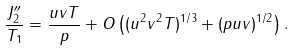Convert formula to latex. <formula><loc_0><loc_0><loc_500><loc_500>\frac { J _ { 2 } ^ { \prime \prime } } { T _ { 1 } } = \frac { u v T } { p } + O \left ( ( u ^ { 2 } v ^ { 2 } T ) ^ { 1 / 3 } + ( p u v ) ^ { 1 / 2 } \right ) .</formula> 